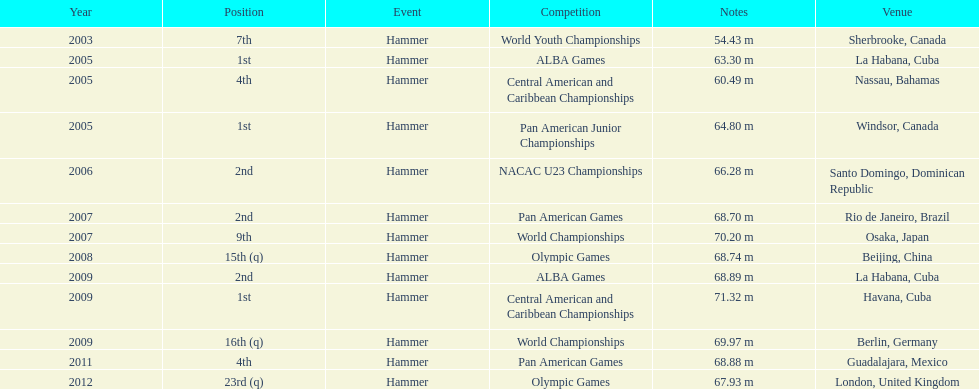What is the number of competitions held in cuba? 3. 